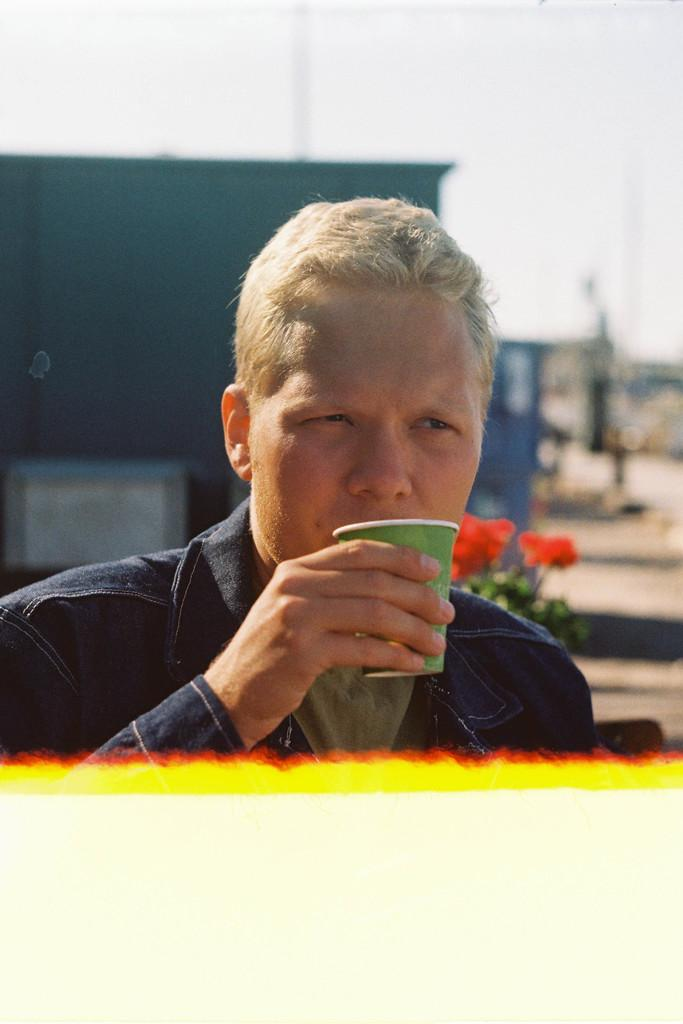Who is present in the image? There is a man in the picture. What is the man holding in his hand? The man is holding a cup in his hand. Can you describe the background of the image? The background of the image is blurred. What type of tramp is the man riding in the image? There is no tramp present in the image; the man is standing and holding a cup. 